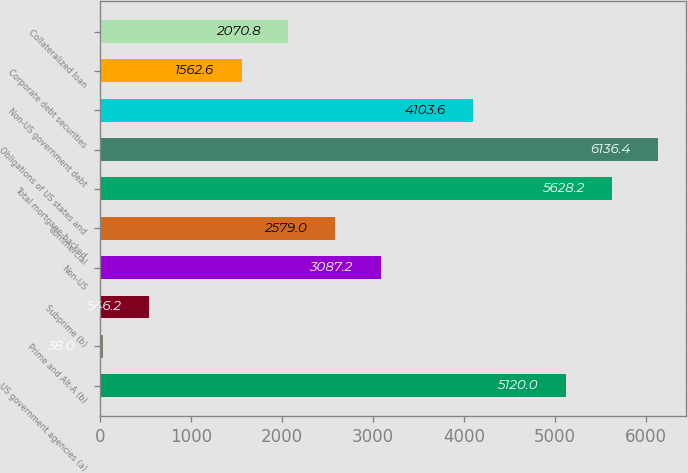<chart> <loc_0><loc_0><loc_500><loc_500><bar_chart><fcel>US government agencies (a)<fcel>Prime and Alt-A (b)<fcel>Subprime (b)<fcel>Non-US<fcel>Commercial<fcel>Total mortgage-backed<fcel>Obligations of US states and<fcel>Non-US government debt<fcel>Corporate debt securities<fcel>Collateralized loan<nl><fcel>5120<fcel>38<fcel>546.2<fcel>3087.2<fcel>2579<fcel>5628.2<fcel>6136.4<fcel>4103.6<fcel>1562.6<fcel>2070.8<nl></chart> 